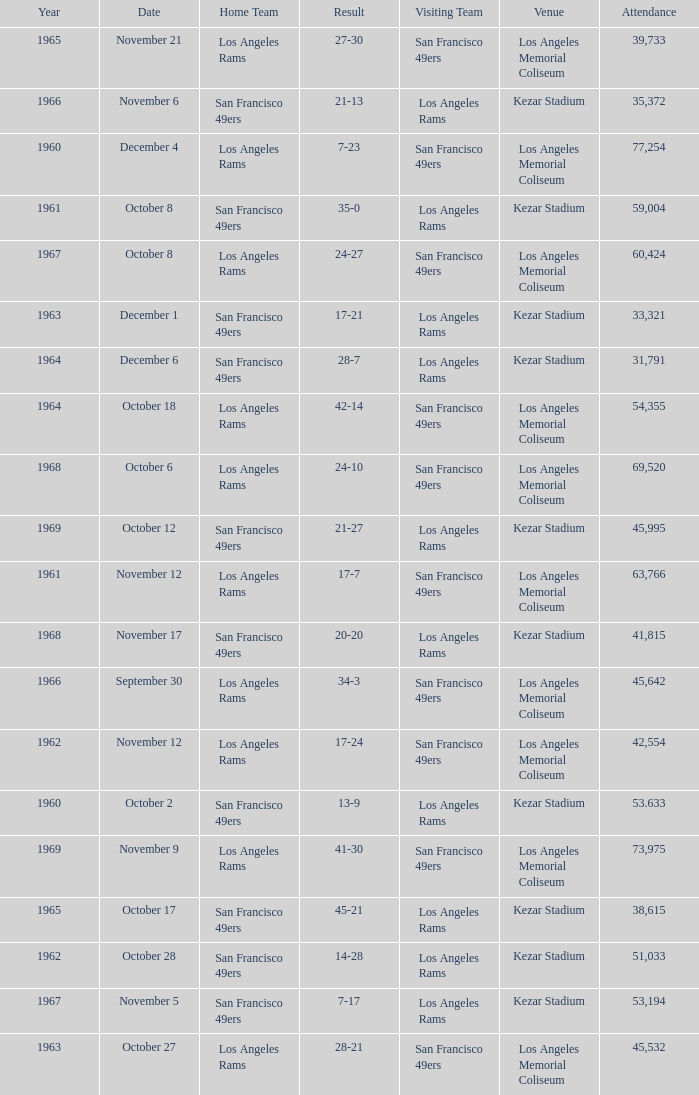When was the earliest year when the attendance was 77,254? 1960.0. 